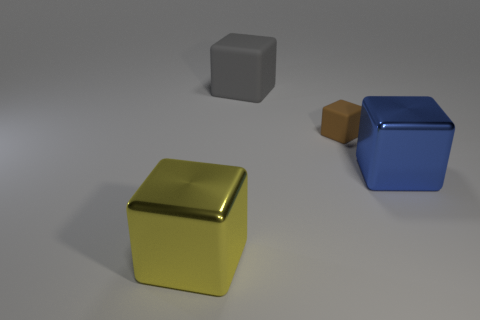Subtract all tiny brown matte blocks. How many blocks are left? 3 Subtract 2 blocks. How many blocks are left? 2 Add 3 big cyan matte spheres. How many objects exist? 7 Subtract all gray cubes. How many cubes are left? 3 Subtract all yellow blocks. Subtract all blue cylinders. How many blocks are left? 3 Subtract all blue things. Subtract all gray things. How many objects are left? 2 Add 1 large blue things. How many large blue things are left? 2 Add 4 large purple cylinders. How many large purple cylinders exist? 4 Subtract 0 brown balls. How many objects are left? 4 